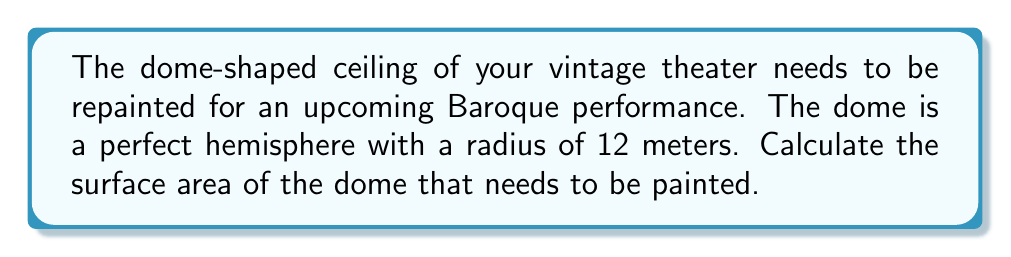Give your solution to this math problem. To calculate the surface area of a dome-shaped ceiling, which is a hemisphere, we can use the formula for the surface area of a sphere and divide it by 2.

Step 1: Recall the formula for the surface area of a sphere:
$$A_{sphere} = 4\pi r^2$$

Step 2: Since we only need half of the sphere (the dome), we divide this formula by 2:
$$A_{dome} = \frac{1}{2} \cdot 4\pi r^2 = 2\pi r^2$$

Step 3: Substitute the given radius (r = 12 meters) into the formula:
$$A_{dome} = 2\pi (12)^2$$

Step 4: Simplify:
$$A_{dome} = 2\pi \cdot 144 = 288\pi$$

Step 5: Calculate the final result:
$$A_{dome} = 288\pi \approx 904.78 \text{ m}^2$$

Therefore, the surface area of the dome-shaped ceiling that needs to be painted is approximately 904.78 square meters.
Answer: $904.78 \text{ m}^2$ 